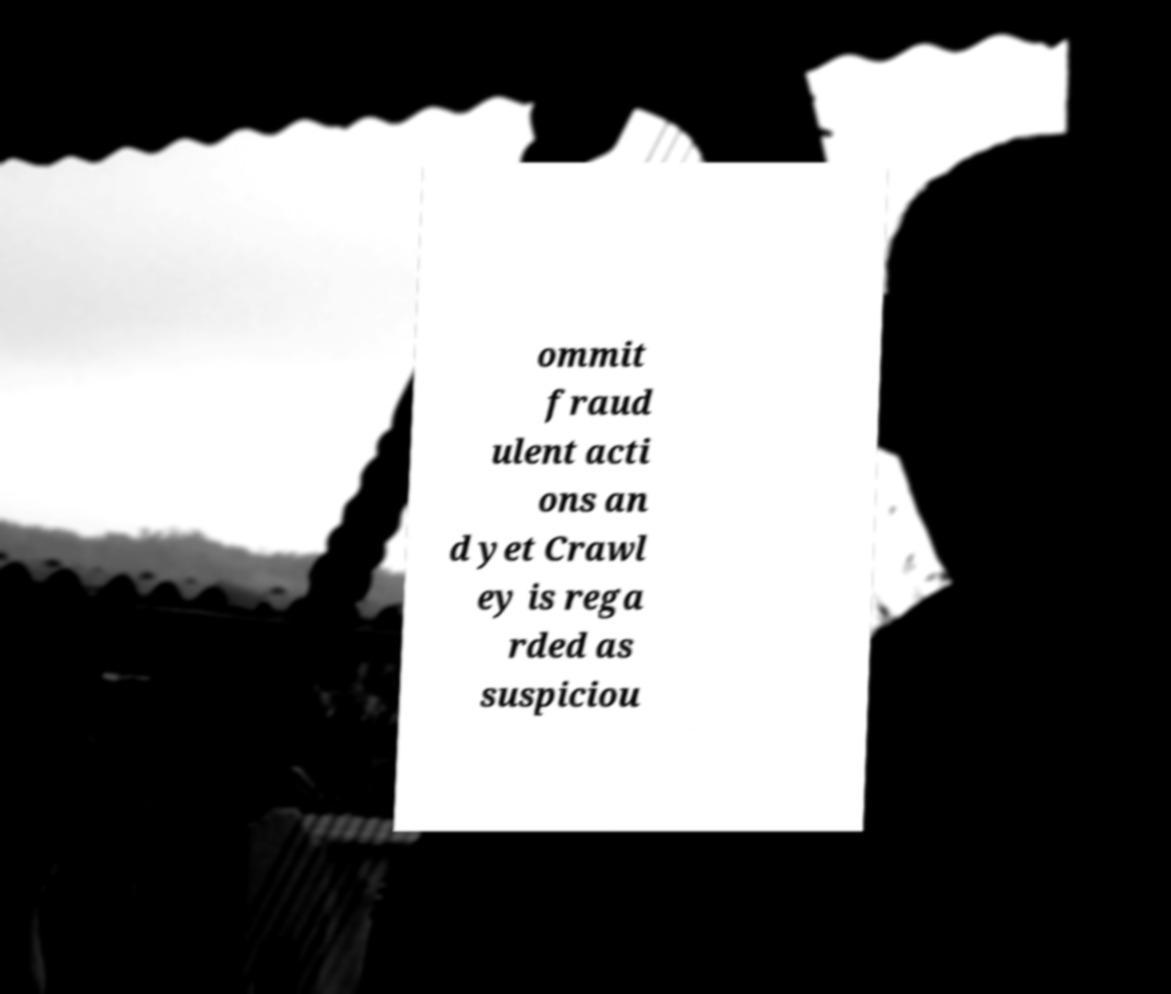What messages or text are displayed in this image? I need them in a readable, typed format. ommit fraud ulent acti ons an d yet Crawl ey is rega rded as suspiciou 